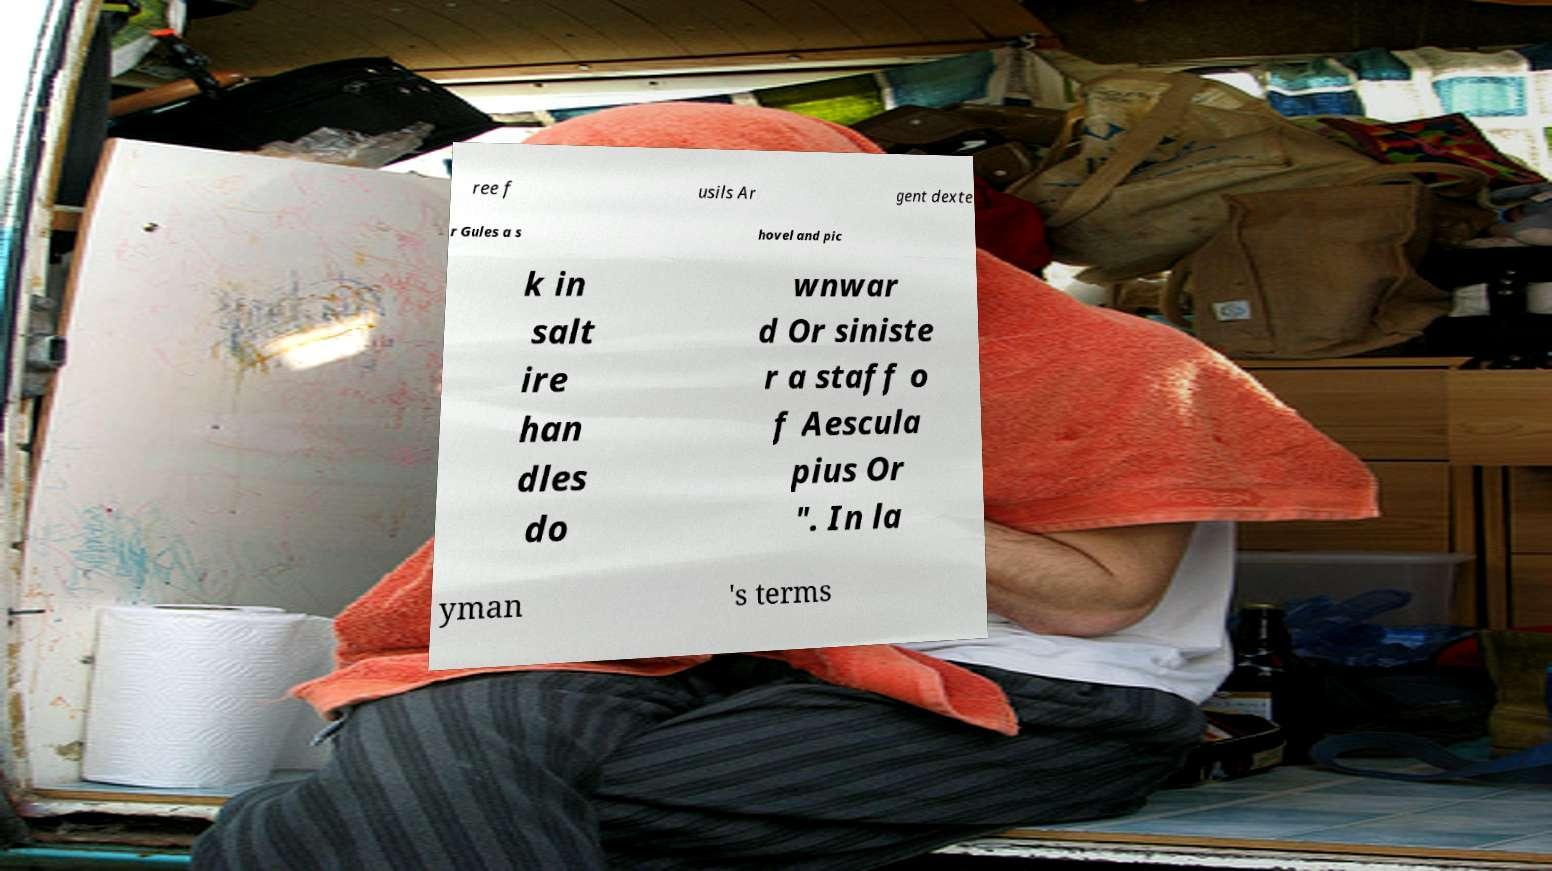Please identify and transcribe the text found in this image. ree f usils Ar gent dexte r Gules a s hovel and pic k in salt ire han dles do wnwar d Or siniste r a staff o f Aescula pius Or ". In la yman 's terms 